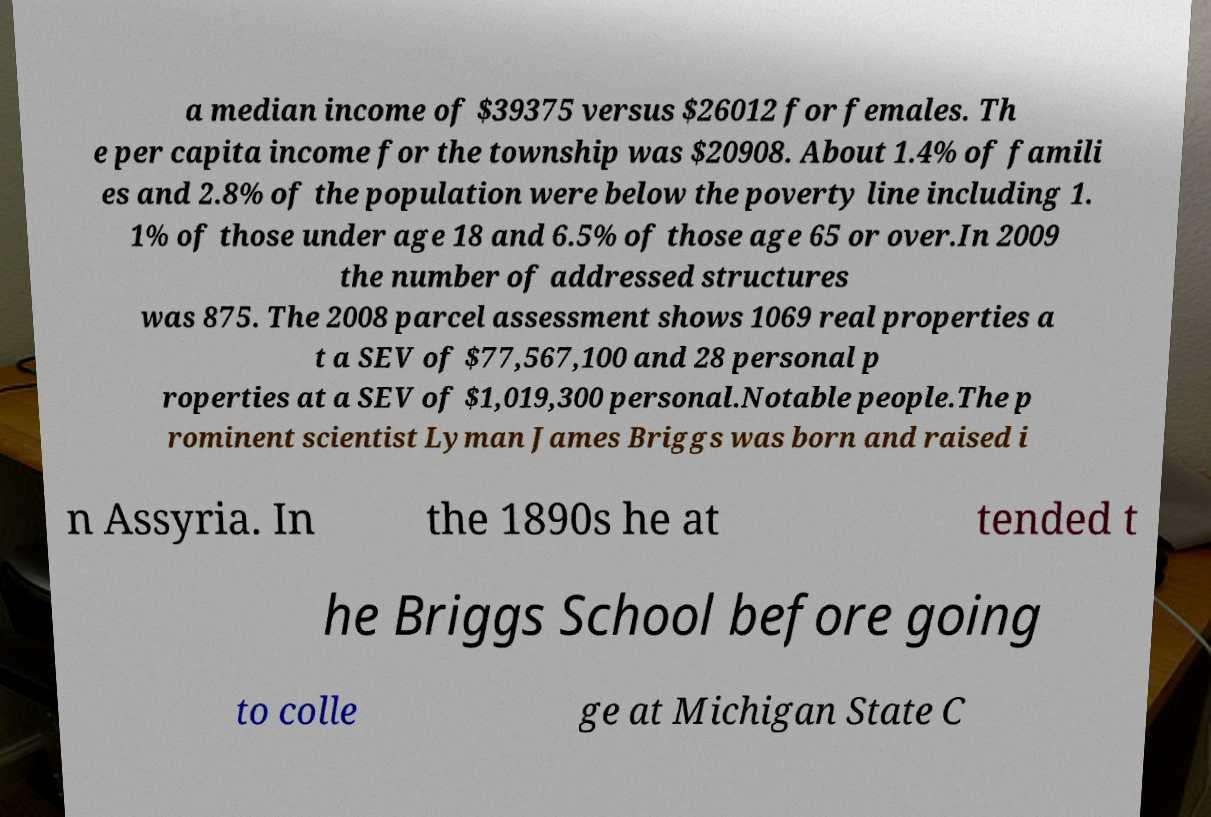Could you assist in decoding the text presented in this image and type it out clearly? a median income of $39375 versus $26012 for females. Th e per capita income for the township was $20908. About 1.4% of famili es and 2.8% of the population were below the poverty line including 1. 1% of those under age 18 and 6.5% of those age 65 or over.In 2009 the number of addressed structures was 875. The 2008 parcel assessment shows 1069 real properties a t a SEV of $77,567,100 and 28 personal p roperties at a SEV of $1,019,300 personal.Notable people.The p rominent scientist Lyman James Briggs was born and raised i n Assyria. In the 1890s he at tended t he Briggs School before going to colle ge at Michigan State C 